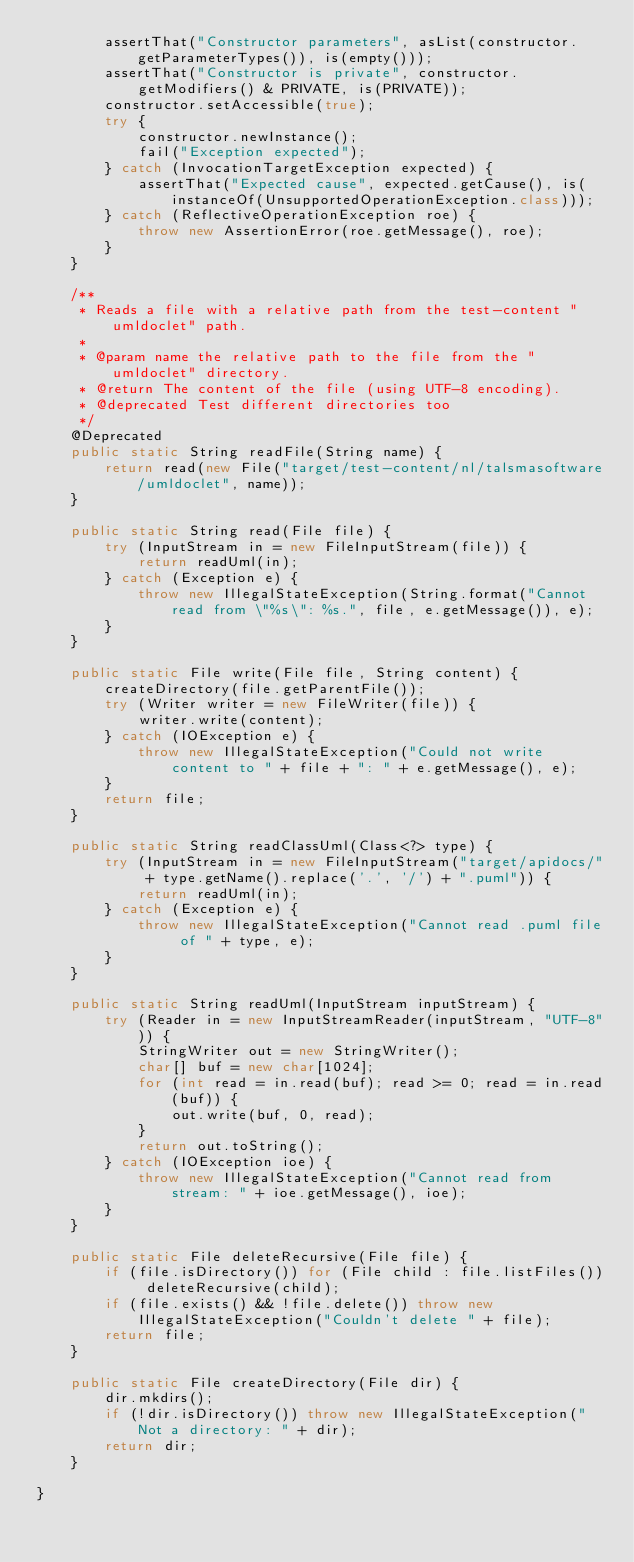Convert code to text. <code><loc_0><loc_0><loc_500><loc_500><_Java_>        assertThat("Constructor parameters", asList(constructor.getParameterTypes()), is(empty()));
        assertThat("Constructor is private", constructor.getModifiers() & PRIVATE, is(PRIVATE));
        constructor.setAccessible(true);
        try {
            constructor.newInstance();
            fail("Exception expected");
        } catch (InvocationTargetException expected) {
            assertThat("Expected cause", expected.getCause(), is(instanceOf(UnsupportedOperationException.class)));
        } catch (ReflectiveOperationException roe) {
            throw new AssertionError(roe.getMessage(), roe);
        }
    }

    /**
     * Reads a file with a relative path from the test-content "umldoclet" path.
     *
     * @param name the relative path to the file from the "umldoclet" directory.
     * @return The content of the file (using UTF-8 encoding).
     * @deprecated Test different directories too
     */
    @Deprecated
    public static String readFile(String name) {
        return read(new File("target/test-content/nl/talsmasoftware/umldoclet", name));
    }

    public static String read(File file) {
        try (InputStream in = new FileInputStream(file)) {
            return readUml(in);
        } catch (Exception e) {
            throw new IllegalStateException(String.format("Cannot read from \"%s\": %s.", file, e.getMessage()), e);
        }
    }

    public static File write(File file, String content) {
        createDirectory(file.getParentFile());
        try (Writer writer = new FileWriter(file)) {
            writer.write(content);
        } catch (IOException e) {
            throw new IllegalStateException("Could not write content to " + file + ": " + e.getMessage(), e);
        }
        return file;
    }

    public static String readClassUml(Class<?> type) {
        try (InputStream in = new FileInputStream("target/apidocs/" + type.getName().replace('.', '/') + ".puml")) {
            return readUml(in);
        } catch (Exception e) {
            throw new IllegalStateException("Cannot read .puml file of " + type, e);
        }
    }

    public static String readUml(InputStream inputStream) {
        try (Reader in = new InputStreamReader(inputStream, "UTF-8")) {
            StringWriter out = new StringWriter();
            char[] buf = new char[1024];
            for (int read = in.read(buf); read >= 0; read = in.read(buf)) {
                out.write(buf, 0, read);
            }
            return out.toString();
        } catch (IOException ioe) {
            throw new IllegalStateException("Cannot read from stream: " + ioe.getMessage(), ioe);
        }
    }

    public static File deleteRecursive(File file) {
        if (file.isDirectory()) for (File child : file.listFiles()) deleteRecursive(child);
        if (file.exists() && !file.delete()) throw new IllegalStateException("Couldn't delete " + file);
        return file;
    }

    public static File createDirectory(File dir) {
        dir.mkdirs();
        if (!dir.isDirectory()) throw new IllegalStateException("Not a directory: " + dir);
        return dir;
    }

}
</code> 